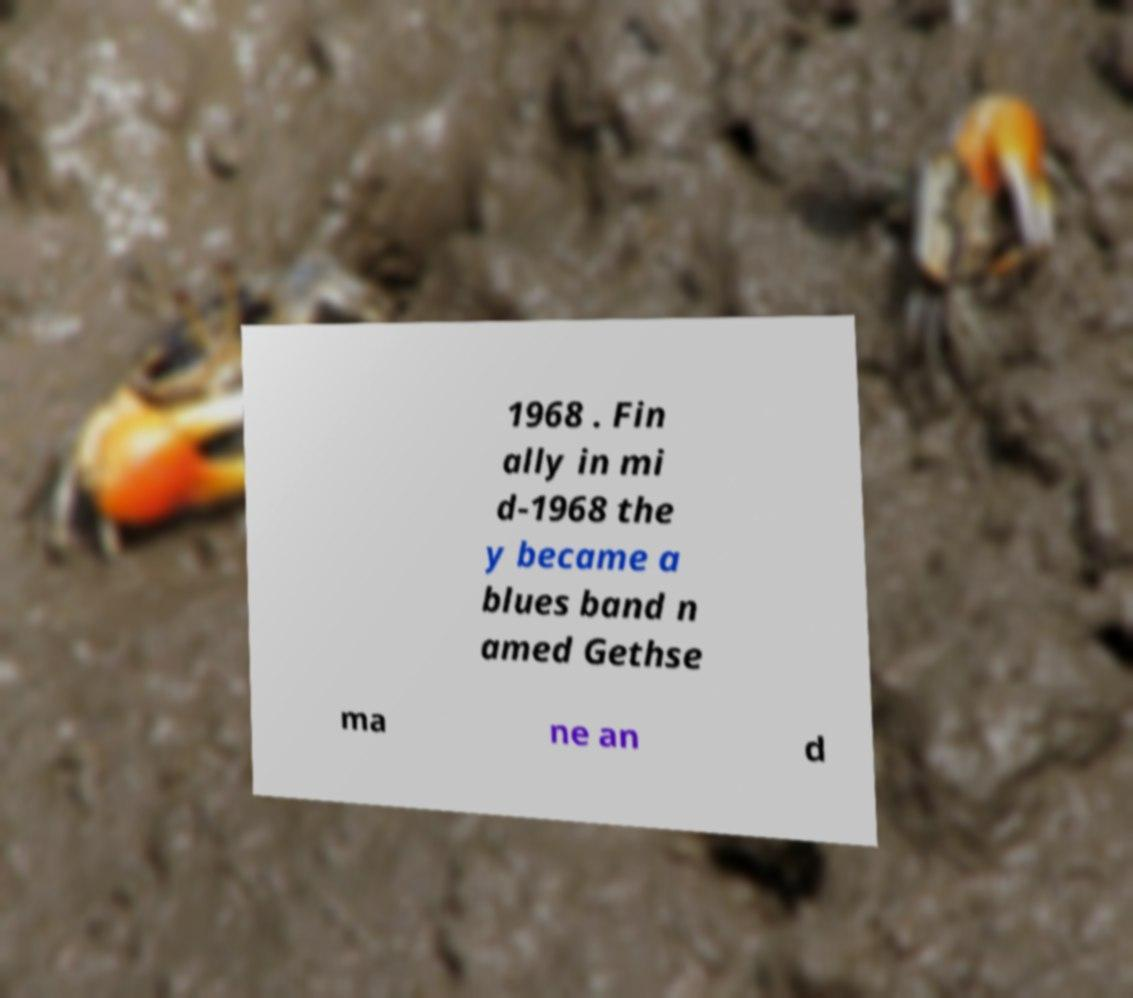Could you extract and type out the text from this image? 1968 . Fin ally in mi d-1968 the y became a blues band n amed Gethse ma ne an d 